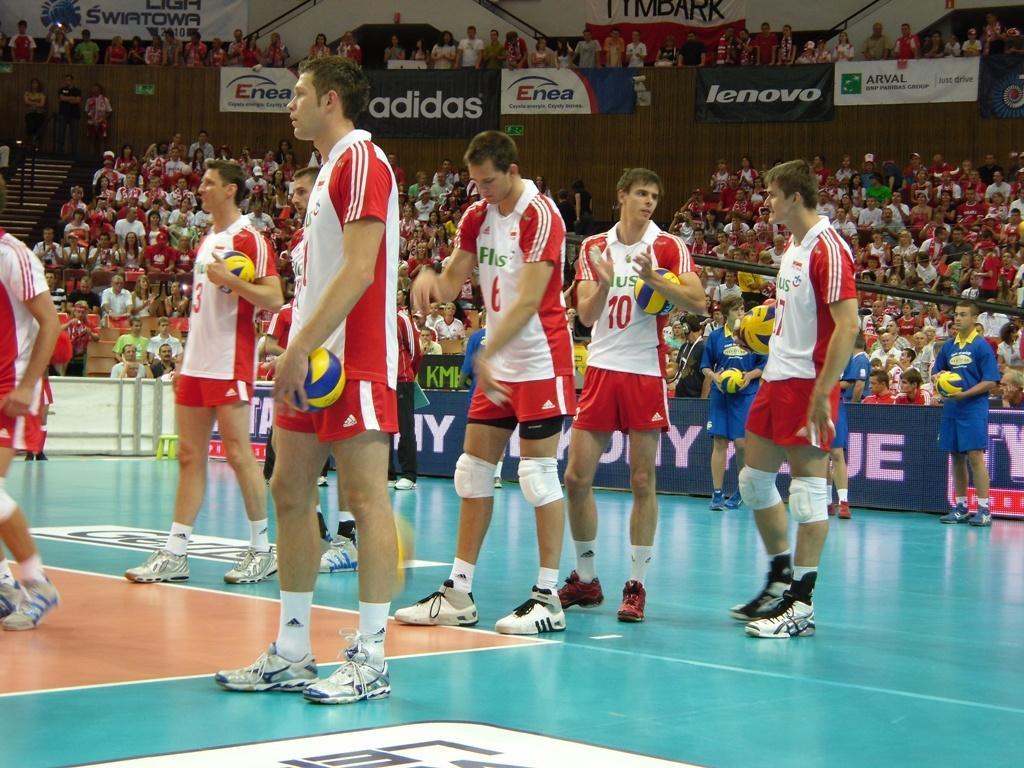How would you summarize this image in a sentence or two? In this image we can see a group of persons standing on the ground, some persons are holding balls in their hands. In the background, we can see a metal pole, group of audience, banners with text and a staircase. 